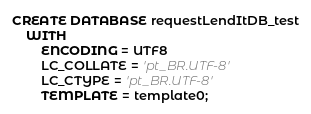Convert code to text. <code><loc_0><loc_0><loc_500><loc_500><_SQL_>CREATE DATABASE requestLendItDB_test
    WITH
        ENCODING = UTF8
        LC_COLLATE = 'pt_BR.UTF-8'
        LC_CTYPE = 'pt_BR.UTF-8'
        TEMPLATE = template0;
</code> 